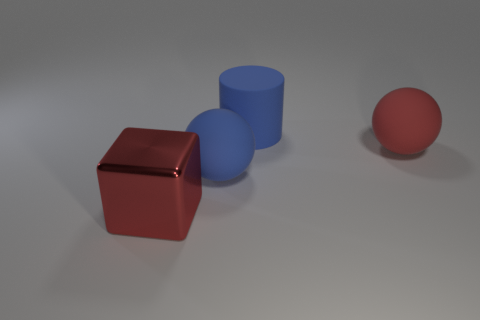Add 2 big blue matte spheres. How many objects exist? 6 Subtract all blocks. How many objects are left? 3 Add 3 blue things. How many blue things are left? 5 Add 4 large red metal cubes. How many large red metal cubes exist? 5 Subtract 0 blue blocks. How many objects are left? 4 Subtract all matte balls. Subtract all large red objects. How many objects are left? 0 